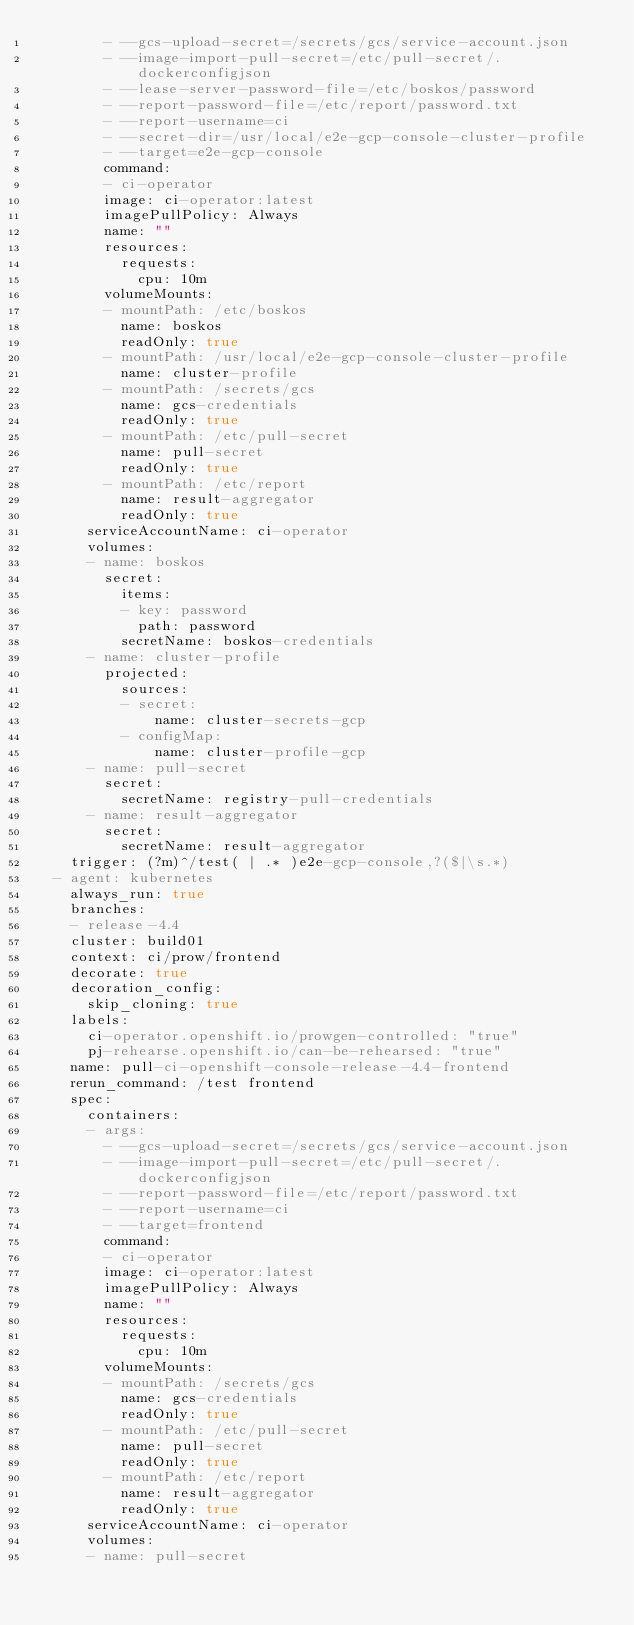<code> <loc_0><loc_0><loc_500><loc_500><_YAML_>        - --gcs-upload-secret=/secrets/gcs/service-account.json
        - --image-import-pull-secret=/etc/pull-secret/.dockerconfigjson
        - --lease-server-password-file=/etc/boskos/password
        - --report-password-file=/etc/report/password.txt
        - --report-username=ci
        - --secret-dir=/usr/local/e2e-gcp-console-cluster-profile
        - --target=e2e-gcp-console
        command:
        - ci-operator
        image: ci-operator:latest
        imagePullPolicy: Always
        name: ""
        resources:
          requests:
            cpu: 10m
        volumeMounts:
        - mountPath: /etc/boskos
          name: boskos
          readOnly: true
        - mountPath: /usr/local/e2e-gcp-console-cluster-profile
          name: cluster-profile
        - mountPath: /secrets/gcs
          name: gcs-credentials
          readOnly: true
        - mountPath: /etc/pull-secret
          name: pull-secret
          readOnly: true
        - mountPath: /etc/report
          name: result-aggregator
          readOnly: true
      serviceAccountName: ci-operator
      volumes:
      - name: boskos
        secret:
          items:
          - key: password
            path: password
          secretName: boskos-credentials
      - name: cluster-profile
        projected:
          sources:
          - secret:
              name: cluster-secrets-gcp
          - configMap:
              name: cluster-profile-gcp
      - name: pull-secret
        secret:
          secretName: registry-pull-credentials
      - name: result-aggregator
        secret:
          secretName: result-aggregator
    trigger: (?m)^/test( | .* )e2e-gcp-console,?($|\s.*)
  - agent: kubernetes
    always_run: true
    branches:
    - release-4.4
    cluster: build01
    context: ci/prow/frontend
    decorate: true
    decoration_config:
      skip_cloning: true
    labels:
      ci-operator.openshift.io/prowgen-controlled: "true"
      pj-rehearse.openshift.io/can-be-rehearsed: "true"
    name: pull-ci-openshift-console-release-4.4-frontend
    rerun_command: /test frontend
    spec:
      containers:
      - args:
        - --gcs-upload-secret=/secrets/gcs/service-account.json
        - --image-import-pull-secret=/etc/pull-secret/.dockerconfigjson
        - --report-password-file=/etc/report/password.txt
        - --report-username=ci
        - --target=frontend
        command:
        - ci-operator
        image: ci-operator:latest
        imagePullPolicy: Always
        name: ""
        resources:
          requests:
            cpu: 10m
        volumeMounts:
        - mountPath: /secrets/gcs
          name: gcs-credentials
          readOnly: true
        - mountPath: /etc/pull-secret
          name: pull-secret
          readOnly: true
        - mountPath: /etc/report
          name: result-aggregator
          readOnly: true
      serviceAccountName: ci-operator
      volumes:
      - name: pull-secret</code> 